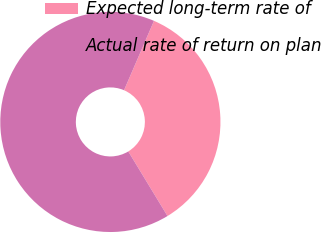<chart> <loc_0><loc_0><loc_500><loc_500><pie_chart><fcel>Expected long-term rate of<fcel>Actual rate of return on plan<nl><fcel>34.83%<fcel>65.17%<nl></chart> 